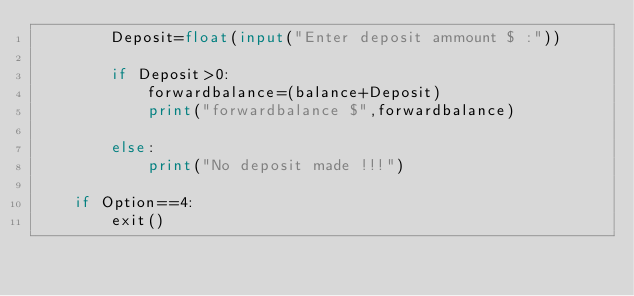Convert code to text. <code><loc_0><loc_0><loc_500><loc_500><_Python_>        Deposit=float(input("Enter deposit ammount $ :"))

        if Deposit>0:
            forwardbalance=(balance+Deposit)
            print("forwardbalance $",forwardbalance)

        else:
            print("No deposit made !!!")
    
    if Option==4:
        exit()
</code> 